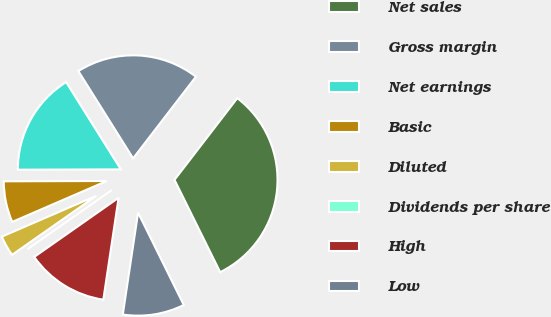<chart> <loc_0><loc_0><loc_500><loc_500><pie_chart><fcel>Net sales<fcel>Gross margin<fcel>Net earnings<fcel>Basic<fcel>Diluted<fcel>Dividends per share<fcel>High<fcel>Low<nl><fcel>32.25%<fcel>19.35%<fcel>16.13%<fcel>6.45%<fcel>3.23%<fcel>0.0%<fcel>12.9%<fcel>9.68%<nl></chart> 